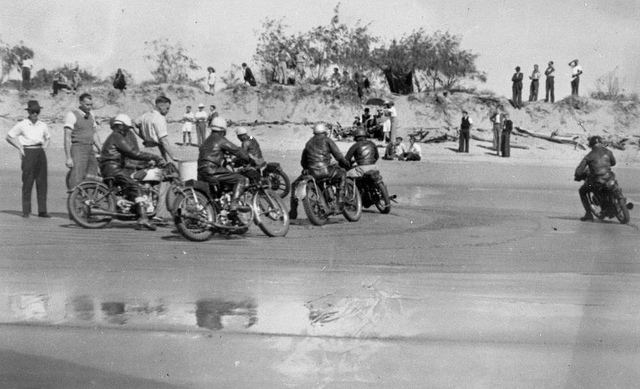What kind of stories do you think the spectators might share after watching this event? Spectators might share tales of the close calls and near-misses they witnessed, the exceptional skill of certain racers, and the exhilarating atmosphere of the event. They might recount the sense of excitement as they cheered for their favorites, the sound of engines roaring and the sight of sand flying as the motorcycles sped past. Some might speak nostalgically about the camaraderie among the crowd, families spread out on blankets, children playing in the sand, and the overall sense of a community coming together to enjoy a thrilling spectacle. Think about the setting in a futuristic scenario. How might a similar race look in 50 years? In 50 years, a similar beach motorcycle race could look drastically different, blending advanced technology with the timeless thrill of racing. The motorcycles might be sleek, electric models with futuristic designs, capable of incredible speeds while remaining almost silent. Riders might wear advanced aerodynamic suits with integrated technology for communication and monitoring, ensuring maximum performance and safety. The beach could be equipped with high-tech facilities, including drones providing live aerial coverage and augmented reality displays enhancing the viewing experience for spectators. Despite the technological advancements, the core spirit of competition and community would remain, drawing people together to celebrate their shared passion. 